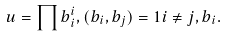Convert formula to latex. <formula><loc_0><loc_0><loc_500><loc_500>u = \prod b _ { i } ^ { i } , ( b _ { i } , b _ { j } ) = 1 i \neq j , b _ { i } .</formula> 